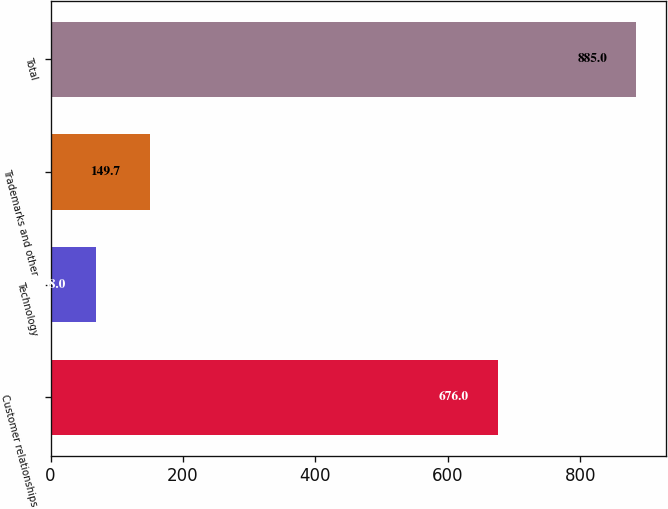Convert chart to OTSL. <chart><loc_0><loc_0><loc_500><loc_500><bar_chart><fcel>Customer relationships<fcel>Technology<fcel>Trademarks and other<fcel>Total<nl><fcel>676<fcel>68<fcel>149.7<fcel>885<nl></chart> 